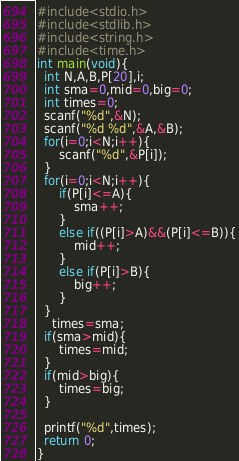<code> <loc_0><loc_0><loc_500><loc_500><_C_>#include<stdio.h>
#include<stdlib.h>
#include<string.h>
#include<time.h>
int main(void){
  int N,A,B,P[20],i;
  int sma=0,mid=0,big=0;
  int times=0;
  scanf("%d",&N);
  scanf("%d %d",&A,&B);
  for(i=0;i<N;i++){
      scanf("%d",&P[i]);
  }
  for(i=0;i<N;i++){
      if(P[i]<=A){
          sma++;
      }
      else if((P[i]>A)&&(P[i]<=B)){
          mid++;
      }
      else if(P[i]>B){
          big++;
      }
  }
    times=sma;
  if(sma>mid){
      times=mid;
  }
  if(mid>big){
      times=big;
  }

  printf("%d",times);
  return 0;
}</code> 